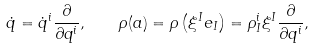Convert formula to latex. <formula><loc_0><loc_0><loc_500><loc_500>\dot { q } = \dot { q } ^ { i } \frac { \partial } { \partial q ^ { i } } , \quad \rho ( a ) = \rho \left ( \xi ^ { I } e _ { I } \right ) = \rho ^ { i } _ { I } \xi ^ { I } \frac { \partial } { \partial q ^ { i } } ,</formula> 